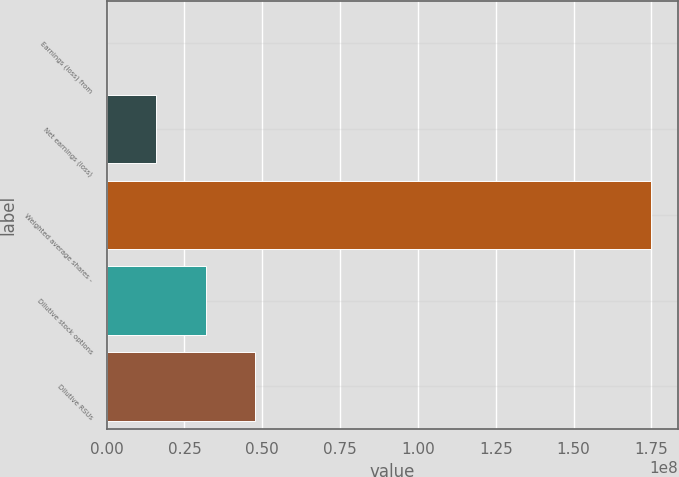Convert chart. <chart><loc_0><loc_0><loc_500><loc_500><bar_chart><fcel>Earnings (loss) from<fcel>Net earnings (loss)<fcel>Weighted average shares -<fcel>Dilutive stock options<fcel>Dilutive RSUs<nl><fcel>1101<fcel>1.59344e+07<fcel>1.74734e+08<fcel>3.18677e+07<fcel>4.7801e+07<nl></chart> 